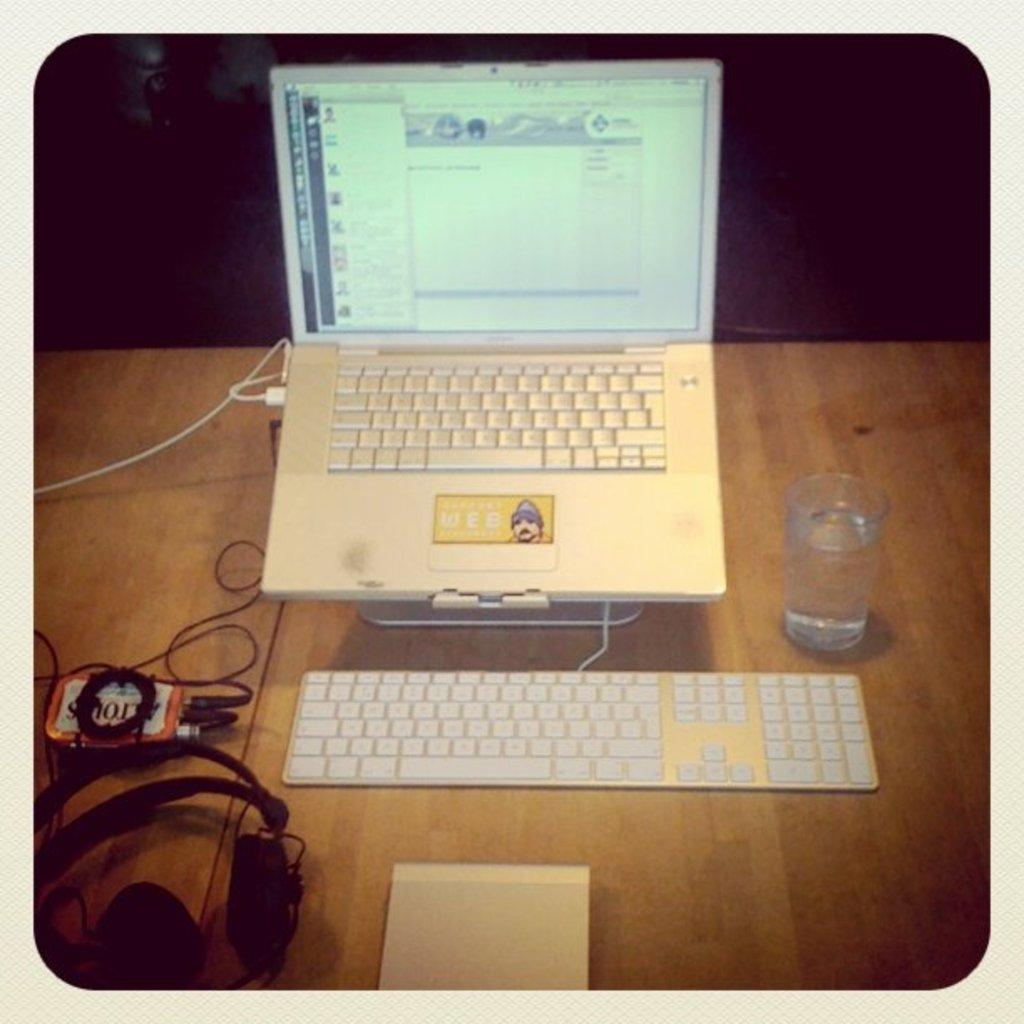<image>
Create a compact narrative representing the image presented. A lap top and keyboard on a desk next to an alttoids can with only a few of the letters of the candy showing. 